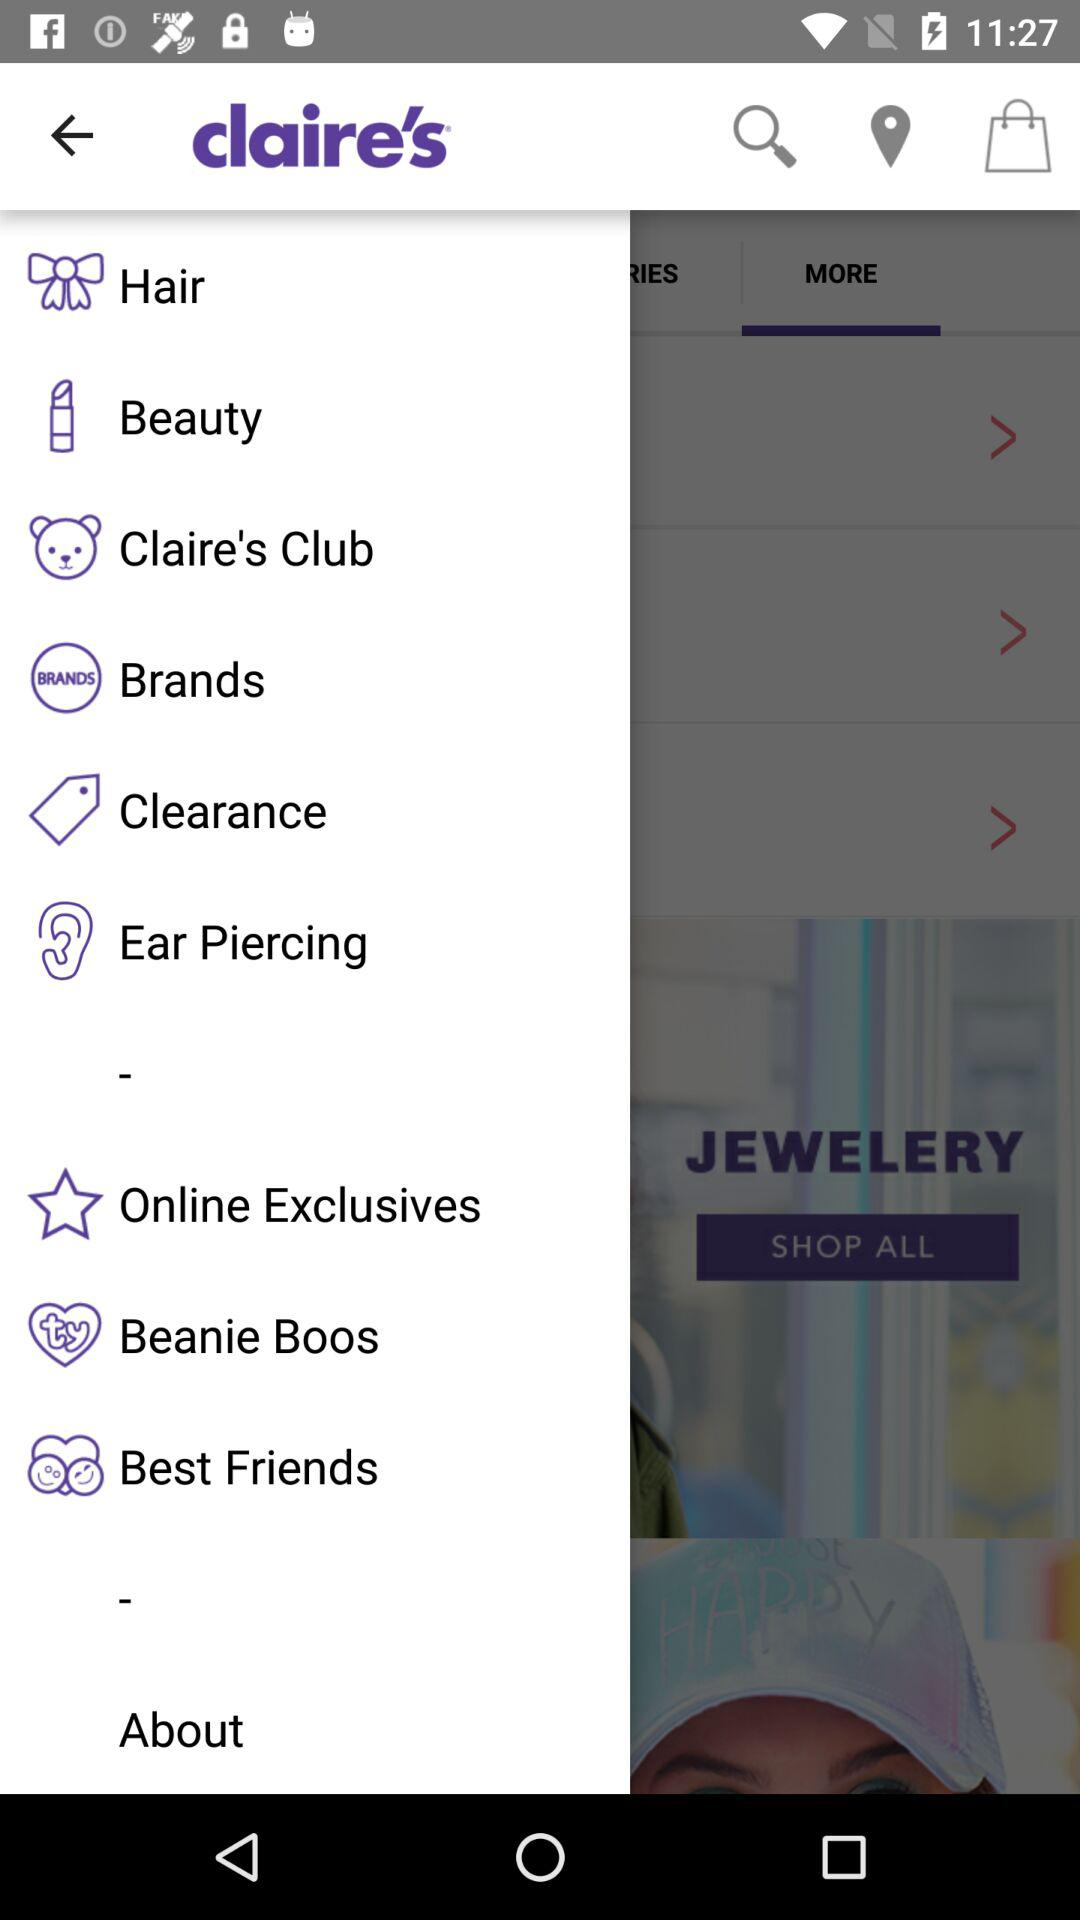What is the name of the application? The name of the application is "claire's". 